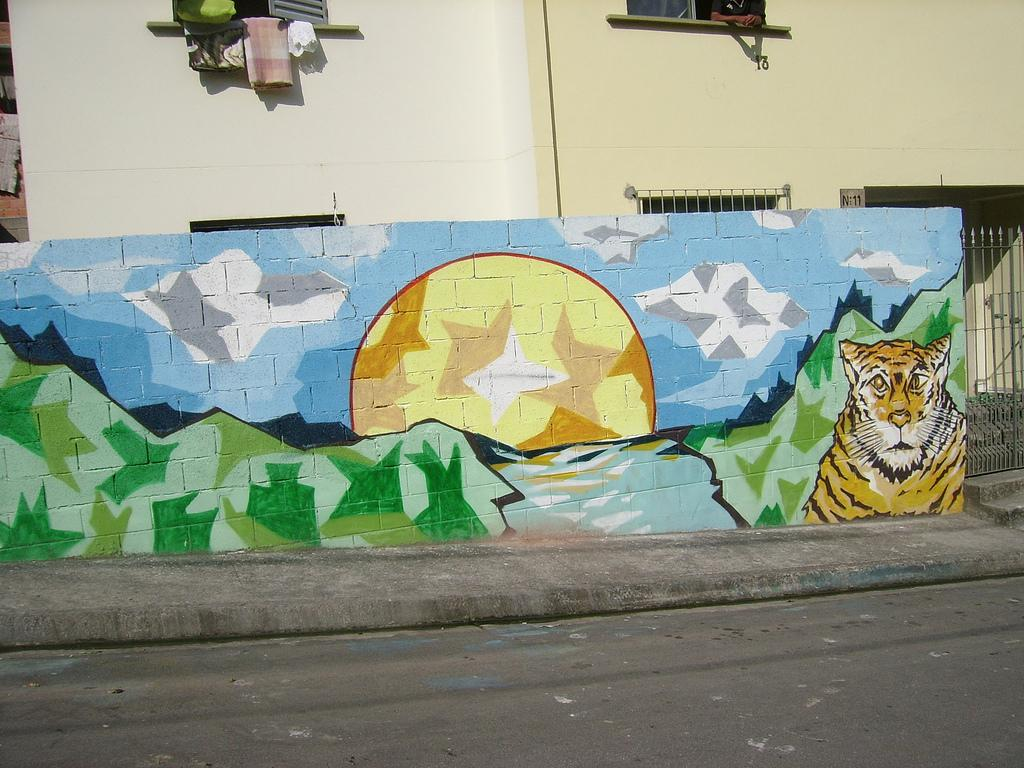What is hanging on the wall in the image? There is a painting on the wall. What can be seen near the window in the image? There are clothes in front of a window. Whose hands are visible in the image? A person's hands are visible in the image. What type of camera is being used to take the picture of the painting? There is no camera present in the image, as it appears to be a still photograph or a painting of the scene. What color is the coat hanging on the wall in the image? There is no coat mentioned in the provided facts, only clothes in front of a window. 